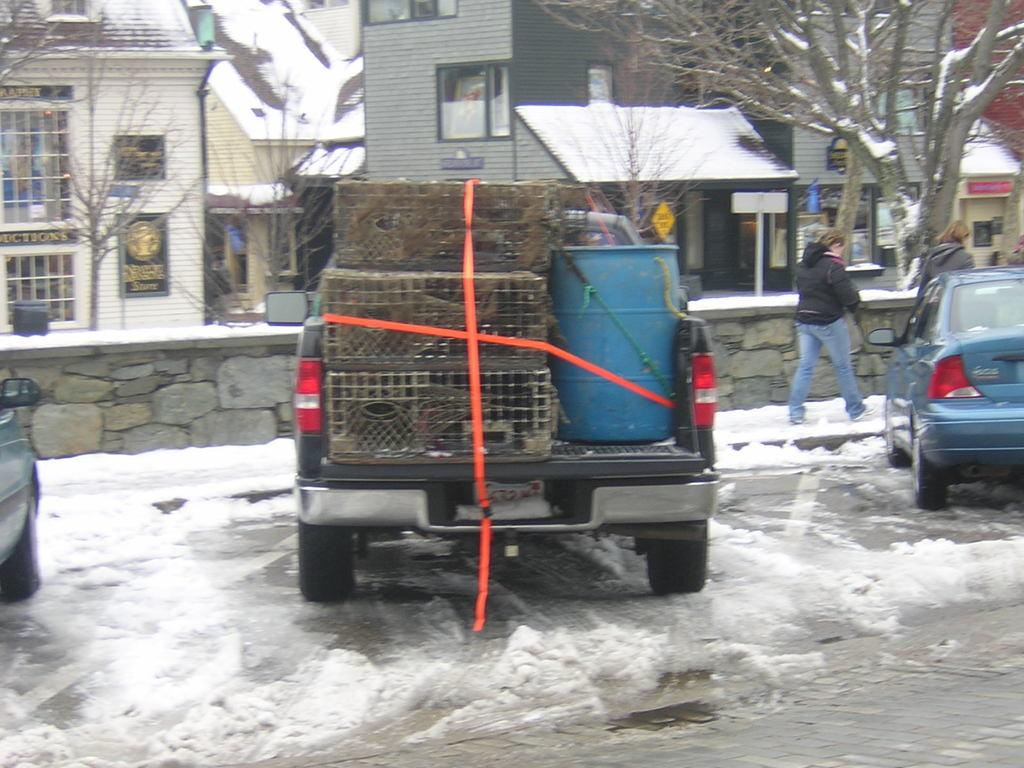What types of objects can be seen in the image? There are vehicles, a person, houses, trees, poles, and sign boards visible in the image. What is the weather condition in the image? There is snow visible in the image, indicating a cold or wintery condition. Can you describe the environment in the image? The image shows a snowy landscape with houses, trees, and poles, suggesting a residential area. Is there a volcano visible in the image? No, there is no volcano present in the image. How much weight can the person in the image lift? There is no information about the person's weightlifting abilities in the image. 